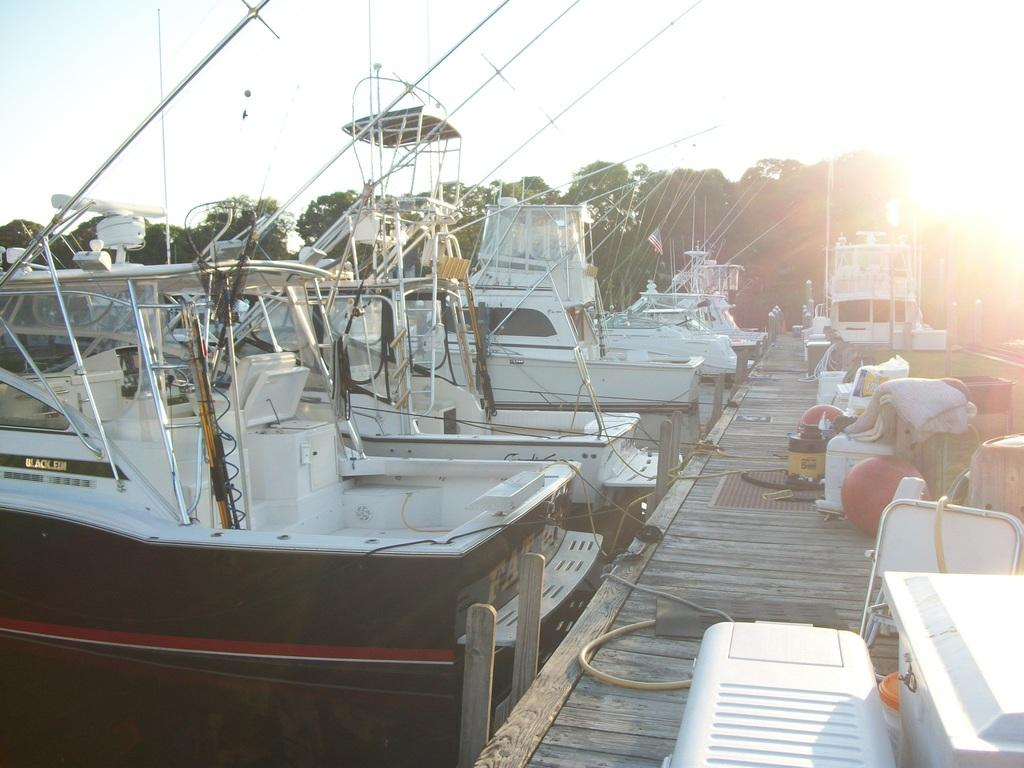What type of vehicles can be seen in the image? There are boats in the image. Where are the boats located? The boats are in a boat yard in the image. What can be seen in the background of the image? The sun, sky, and trees are visible in the background of the image. What type of line can be seen connecting the boats in the image? There is no line connecting the boats in the image; they are separate vessels in the boat yard. 